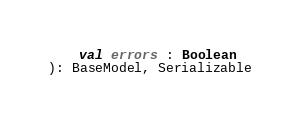Convert code to text. <code><loc_0><loc_0><loc_500><loc_500><_Kotlin_>    val errors : Boolean
): BaseModel, Serializable
</code> 